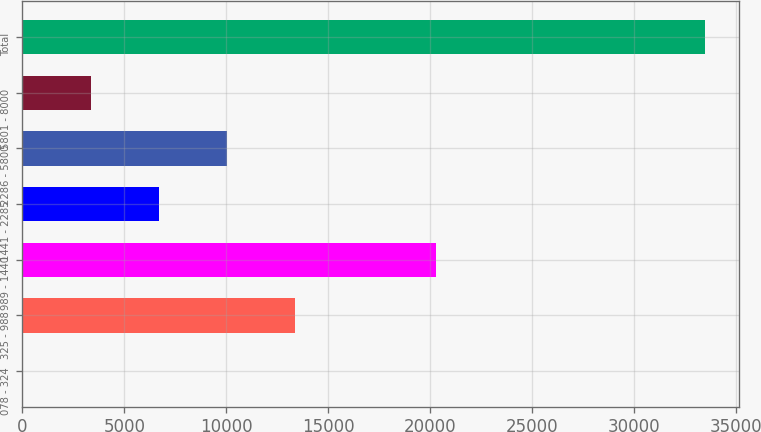Convert chart. <chart><loc_0><loc_0><loc_500><loc_500><bar_chart><fcel>078 - 324<fcel>325 - 988<fcel>989 - 1440<fcel>1441 - 2285<fcel>2286 - 5800<fcel>5801 - 8000<fcel>Total<nl><fcel>4<fcel>13398<fcel>20307<fcel>6701<fcel>10049.5<fcel>3352.5<fcel>33489<nl></chart> 